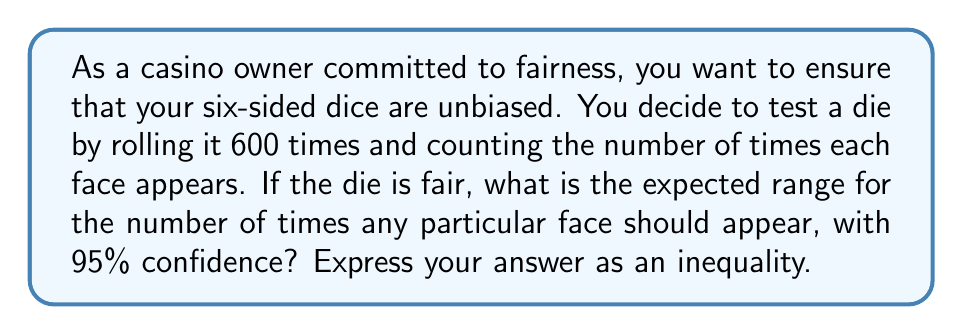Solve this math problem. To solve this problem, we'll use the normal approximation to the binomial distribution and follow these steps:

1) For a fair die, the probability of rolling any particular face is $p = \frac{1}{6}$.

2) In 600 rolls, the expected number of times a particular face appears is:
   $\mu = np = 600 \cdot \frac{1}{6} = 100$

3) The standard deviation for this binomial distribution is:
   $\sigma = \sqrt{np(1-p)} = \sqrt{600 \cdot \frac{1}{6} \cdot \frac{5}{6}} = \sqrt{500/6} \approx 9.13$

4) For a 95% confidence interval, we use $z = 1.96$ (from the standard normal distribution table).

5) The range is given by $\mu \pm z\sigma$:
   $100 \pm 1.96 \cdot 9.13 = 100 \pm 17.89$

6) Therefore, the range is approximately $[82.11, 117.89]$

7) Rounding to the nearest whole number (since we're counting discrete events), we get $[82, 118]$

Thus, with 95% confidence, we expect the number of times $x$ that any particular face appears to satisfy the inequality:

$$82 \leq x \leq 118$$
Answer: $82 \leq x \leq 118$ 